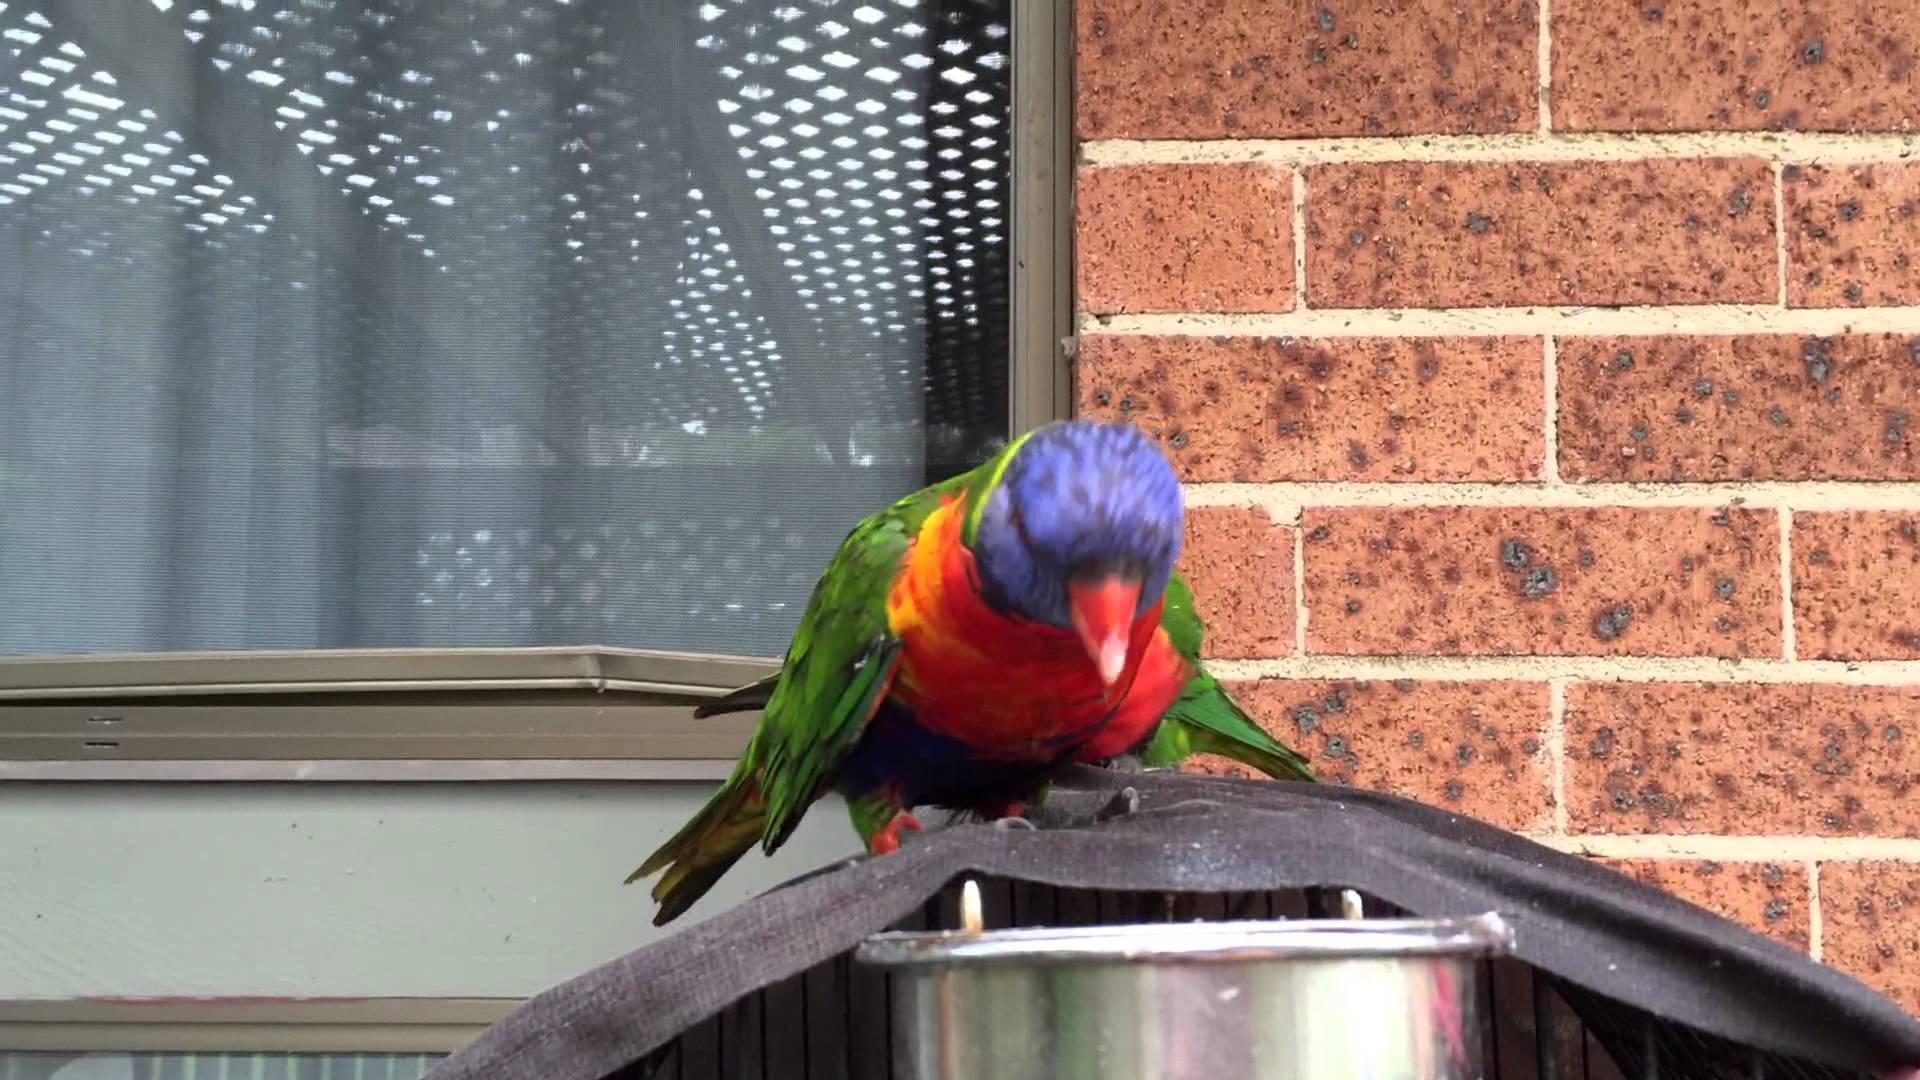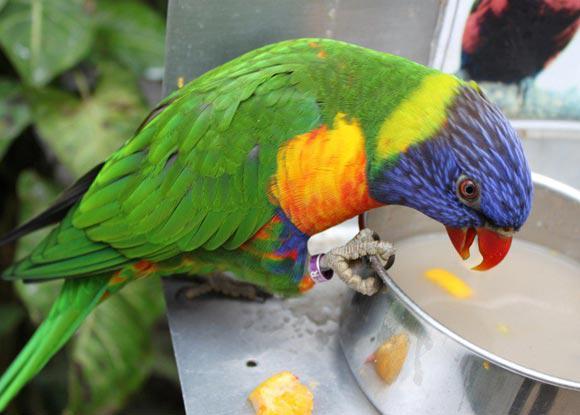The first image is the image on the left, the second image is the image on the right. Evaluate the accuracy of this statement regarding the images: "Only one parrot can be seen in each of the images.". Is it true? Answer yes or no. Yes. The first image is the image on the left, the second image is the image on the right. Analyze the images presented: Is the assertion "There is a bird that is hanging with its feet above most of its body." valid? Answer yes or no. No. 